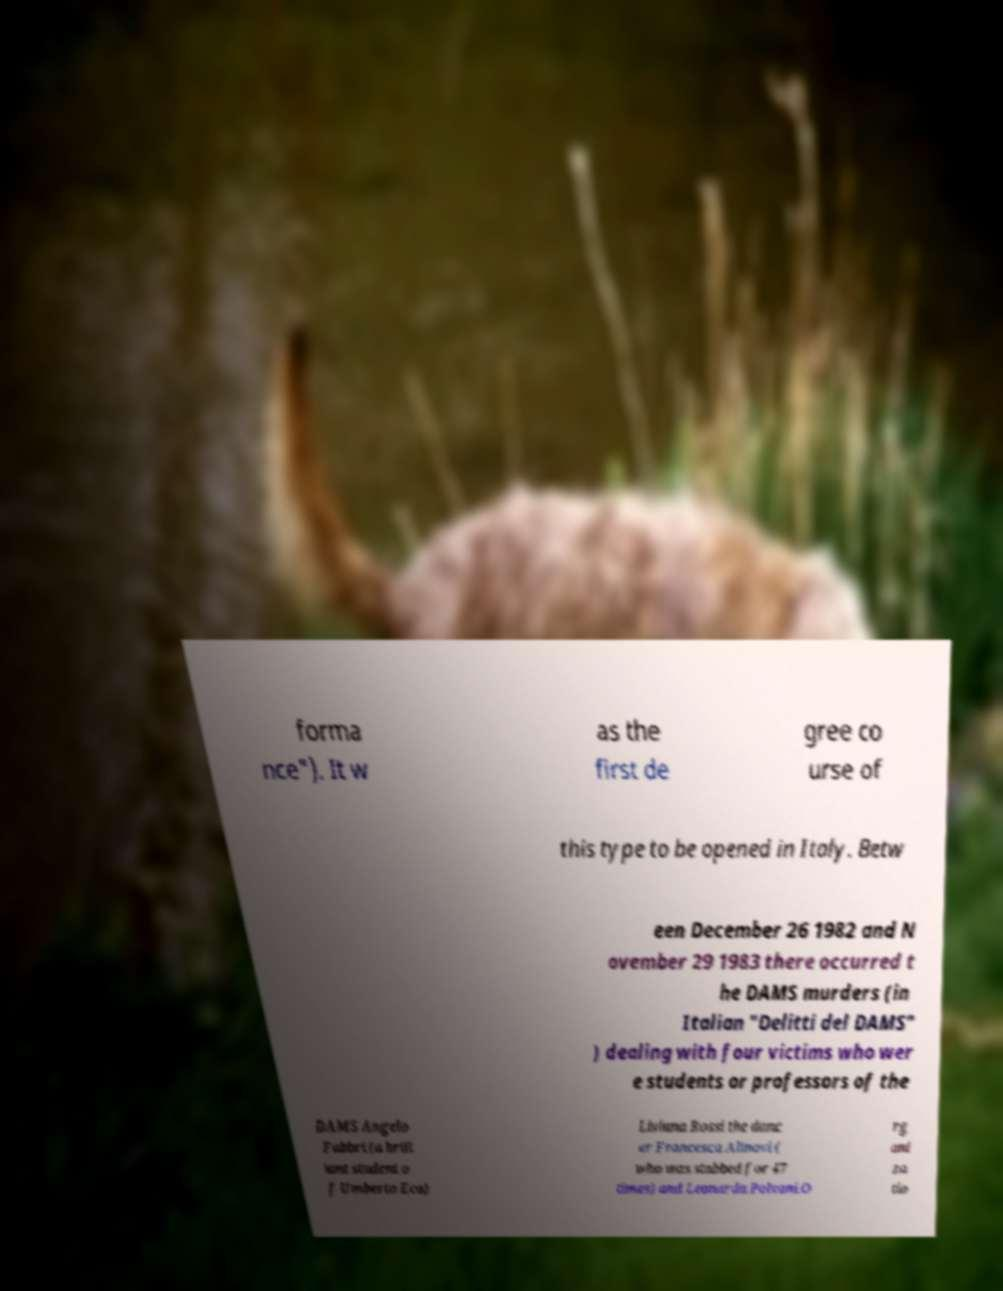Could you assist in decoding the text presented in this image and type it out clearly? forma nce"). It w as the first de gree co urse of this type to be opened in Italy. Betw een December 26 1982 and N ovember 29 1983 there occurred t he DAMS murders (in Italian "Delitti del DAMS" ) dealing with four victims who wer e students or professors of the DAMS Angelo Fabbri (a brill iant student o f Umberto Eco) Liviana Rossi the danc er Francesca Alinovi ( who was stabbed for 47 times) and Leonarda Polvani.O rg ani za tio 